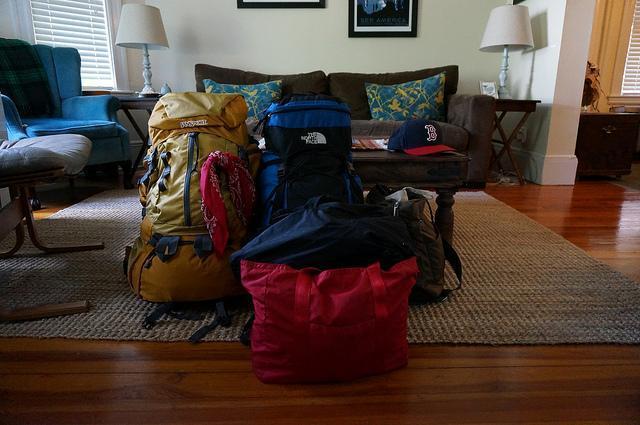How many bags are on the ground?
Give a very brief answer. 5. How many backpacks can be seen?
Give a very brief answer. 4. How many chairs are there?
Give a very brief answer. 2. 